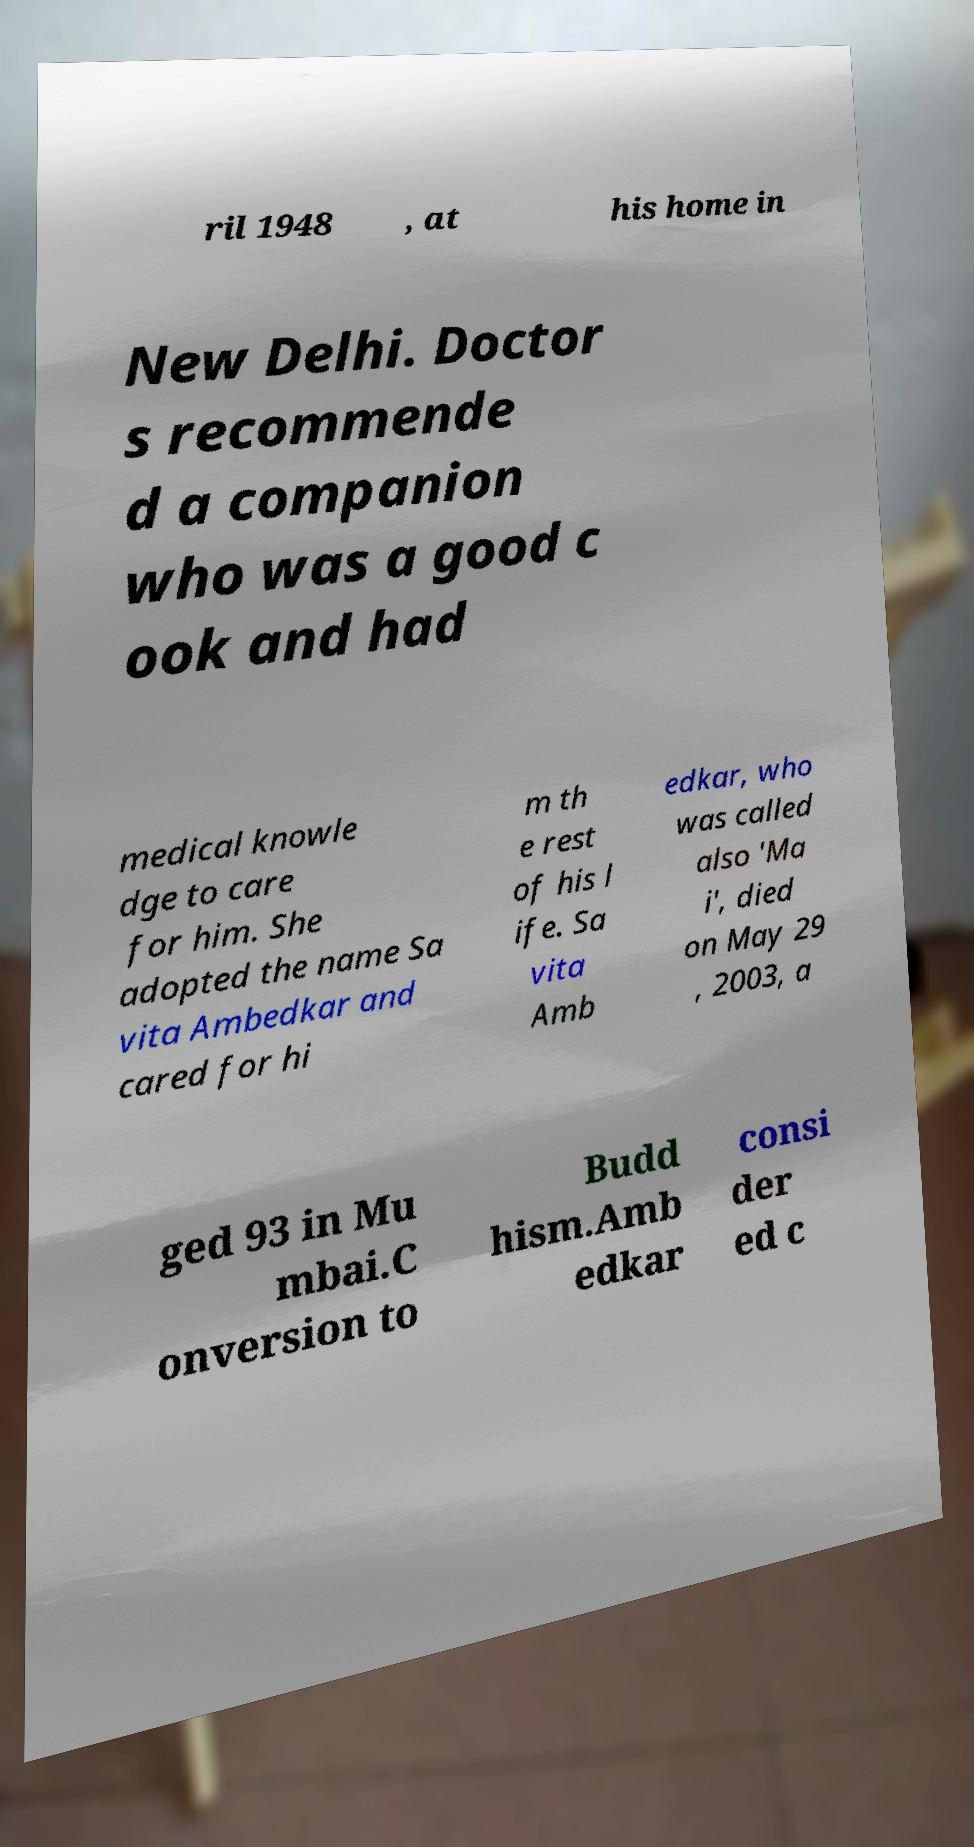For documentation purposes, I need the text within this image transcribed. Could you provide that? ril 1948 , at his home in New Delhi. Doctor s recommende d a companion who was a good c ook and had medical knowle dge to care for him. She adopted the name Sa vita Ambedkar and cared for hi m th e rest of his l ife. Sa vita Amb edkar, who was called also 'Ma i', died on May 29 , 2003, a ged 93 in Mu mbai.C onversion to Budd hism.Amb edkar consi der ed c 